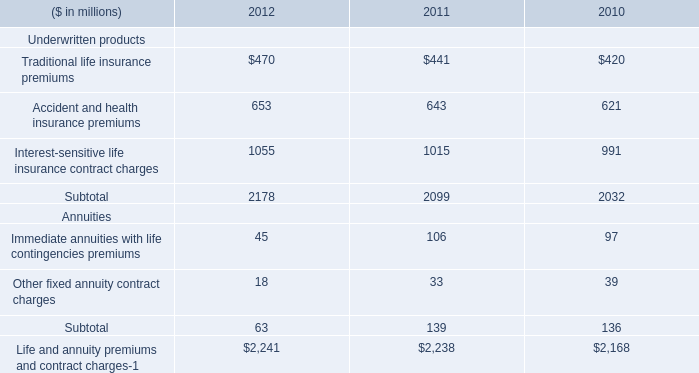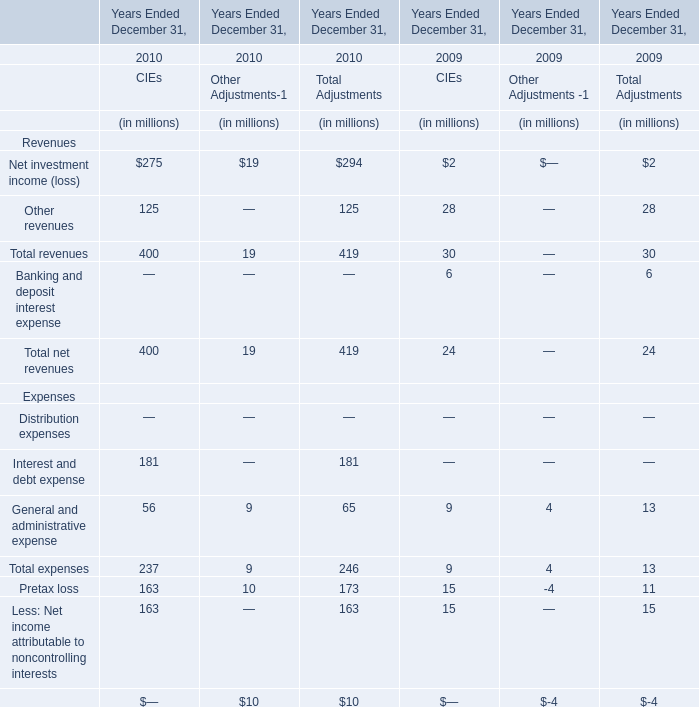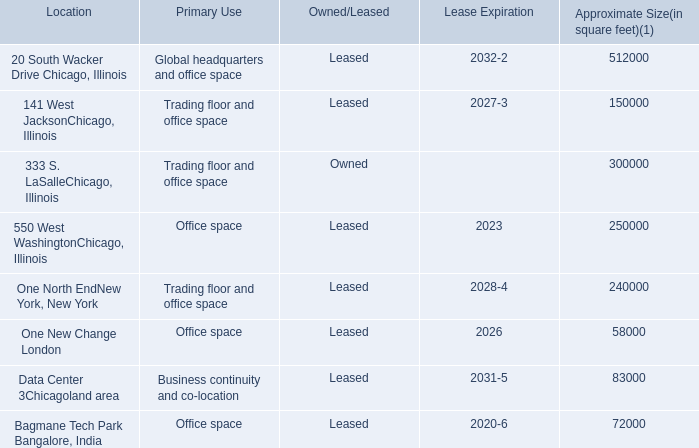What is the ratio of Interest and debt expense of CIEs to the total expenses of CIEs in 2010? 
Computations: (181 / 237)
Answer: 0.76371. 